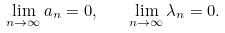<formula> <loc_0><loc_0><loc_500><loc_500>\lim _ { n \to \infty } a _ { n } = 0 , \quad \lim _ { n \to \infty } \lambda _ { n } = 0 .</formula> 